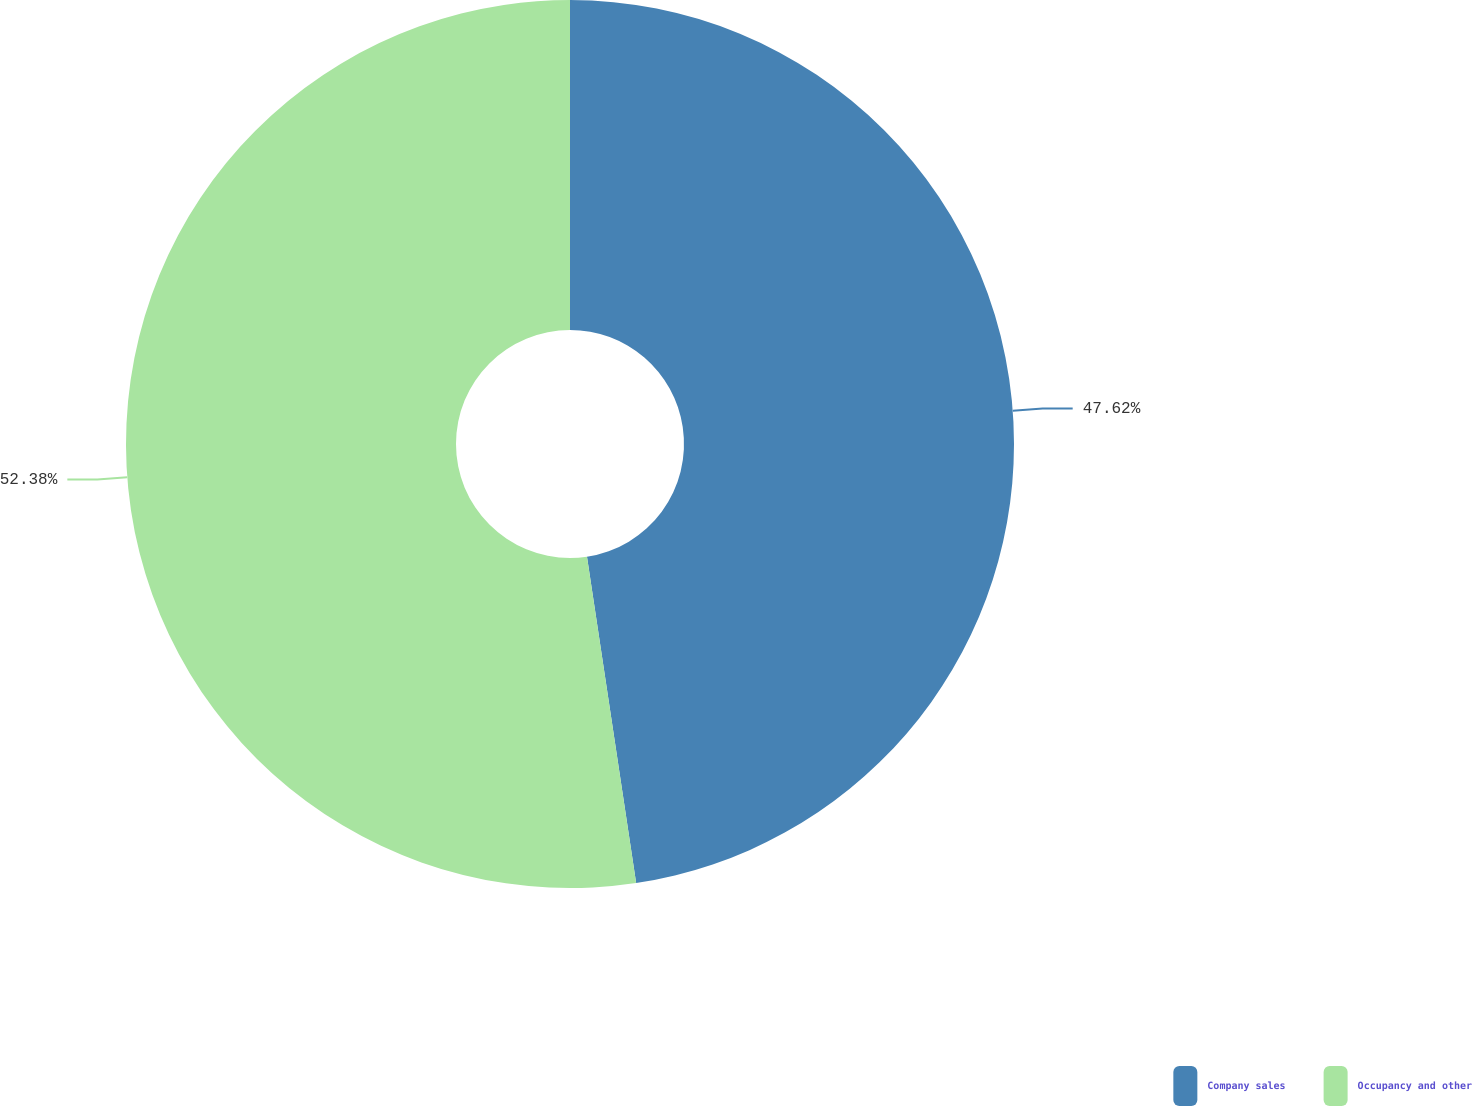<chart> <loc_0><loc_0><loc_500><loc_500><pie_chart><fcel>Company sales<fcel>Occupancy and other<nl><fcel>47.62%<fcel>52.38%<nl></chart> 